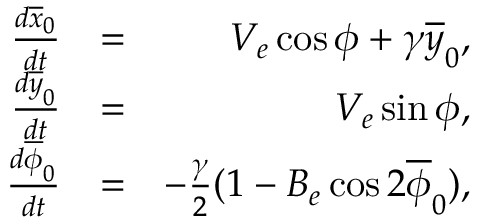Convert formula to latex. <formula><loc_0><loc_0><loc_500><loc_500>\begin{array} { r l r } { \frac { d \overline { x } _ { 0 } } { d t } } & { = } & { V _ { e } \cos \phi + \gamma \overline { y } _ { 0 } , } \\ { \frac { d \overline { y } _ { 0 } } { d t } } & { = } & { V _ { e } \sin \phi , } \\ { \frac { d \overline { \phi } _ { 0 } } { d t } } & { = } & { - \frac { \gamma } { 2 } ( 1 - B _ { e } \cos 2 \overline { \phi } _ { 0 } ) , } \end{array}</formula> 